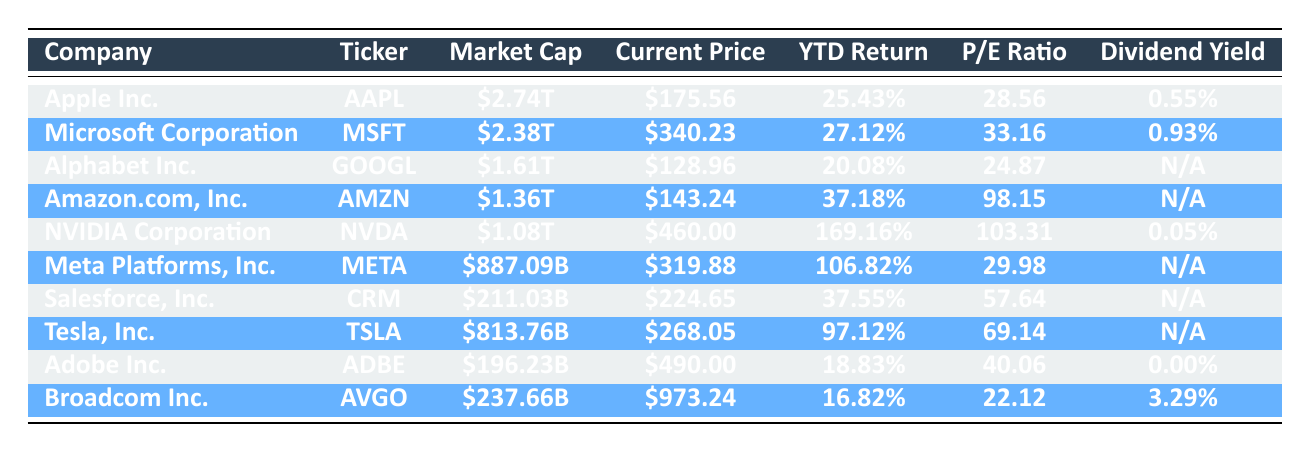What is the current price of Apple Inc.? The current price for Apple Inc. can be found in the "Current Price" column corresponding to the row with "Apple Inc." It lists the current price as $175.56.
Answer: $175.56 Which company has the highest market cap? To find the company with the highest market cap, look at the "Market Cap" column and compare the values. Apple Inc. has the highest market cap at $2.74T.
Answer: Apple Inc Is the P/E ratio for NVIDIA Corporation higher than for Microsoft Corporation? Comparing the P/E ratios, NVIDIA Corporation is listed with a P/E ratio of 103.31 and Microsoft Corporation has a P/E ratio of 33.16. Since 103.31 is greater than 33.16, the statement is true.
Answer: Yes What is the average market cap of these companies? To calculate the average market cap, first convert all market caps to billions: Apple Inc. is 2740B, Microsoft Corporation is 2380B, Alphabet Inc. is 1610B, Amazon.com, Inc. is 1360B, NVIDIA Corporation is 1080B, Meta Platforms, Inc. is 887.09B, Salesforce, Inc. is 211.03B, Tesla, Inc. is 813.76B, Adobe Inc. is 196.23B, and Broadcom Inc. is 237.66B. Then sum these values: 2740 + 2380 + 1610 + 1360 + 1080 + 887.09 + 211.03 + 813.76 + 196.23 + 237.66 = 8,100.78 billion. Finally, divide by 10 (the number of companies) to get the average: 8,100.78B / 10 = 810.078B.
Answer: 810.078B Which companies do not have a dividend yield listed? From the "Dividend Yield" column, the companies without a listed dividend yield are Alphabet Inc., Amazon.com, Inc., Meta Platforms, Inc., Salesforce, Inc., Tesla, Inc.
Answer: Alphabet Inc., Amazon.com, Inc., Meta Platforms, Inc., Salesforce, Inc., Tesla, Inc 